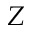Convert formula to latex. <formula><loc_0><loc_0><loc_500><loc_500>Z</formula> 